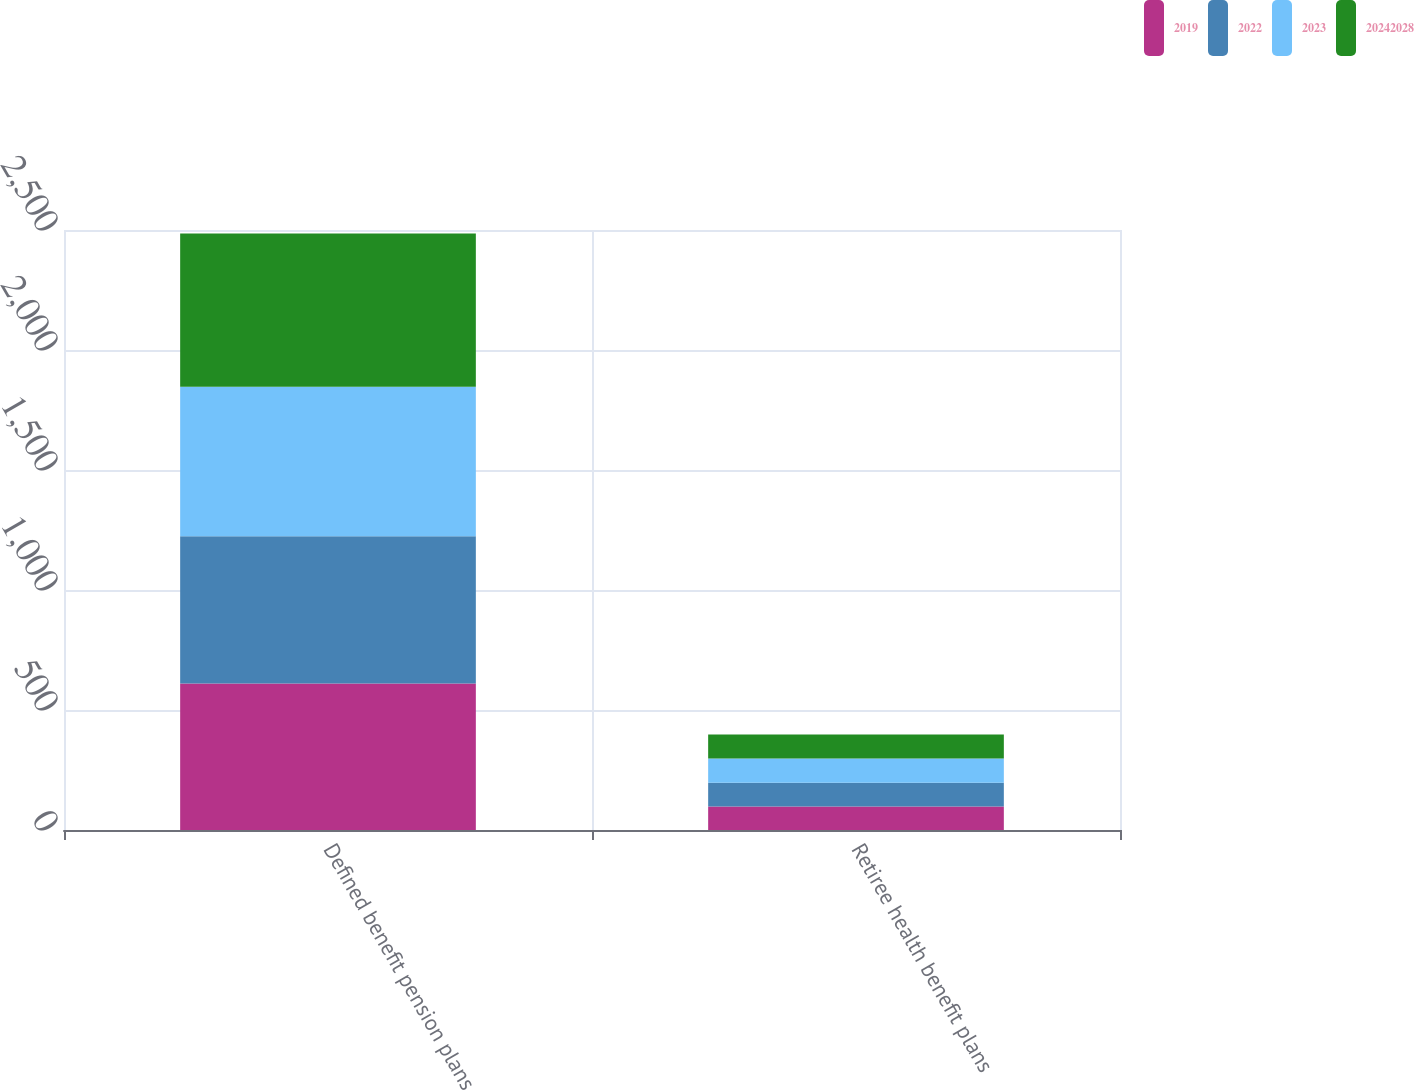Convert chart. <chart><loc_0><loc_0><loc_500><loc_500><stacked_bar_chart><ecel><fcel>Defined benefit pension plans<fcel>Retiree health benefit plans<nl><fcel>2019<fcel>609.9<fcel>98<nl><fcel>2022<fcel>613.6<fcel>99.1<nl><fcel>2023<fcel>623.6<fcel>100.7<nl><fcel>2.0242e+07<fcel>638.2<fcel>99.9<nl></chart> 